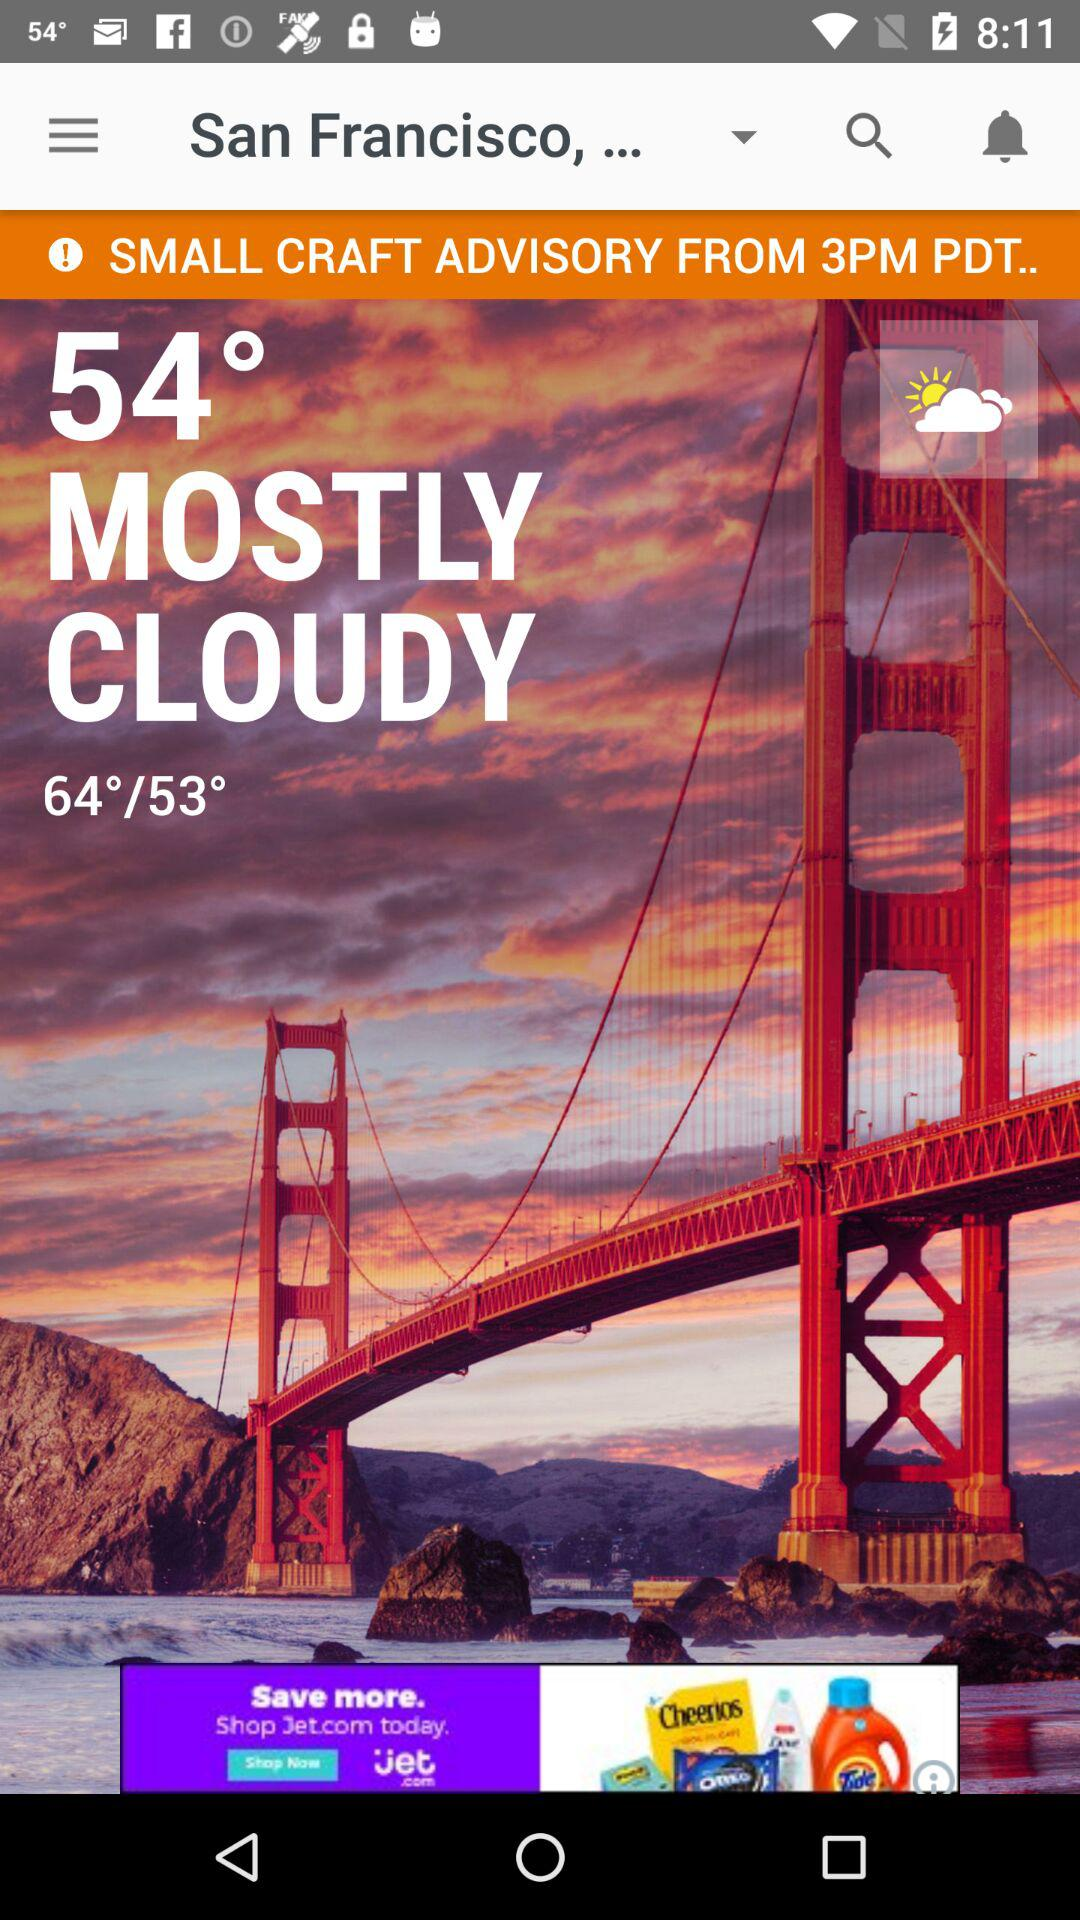How many degrees is the temperature range?
Answer the question using a single word or phrase. 11 